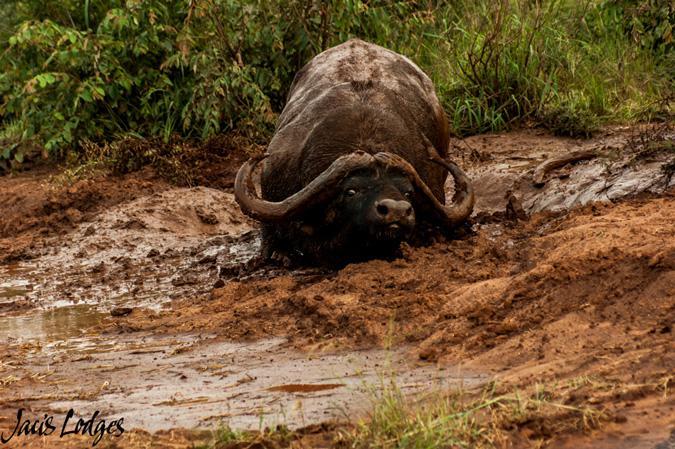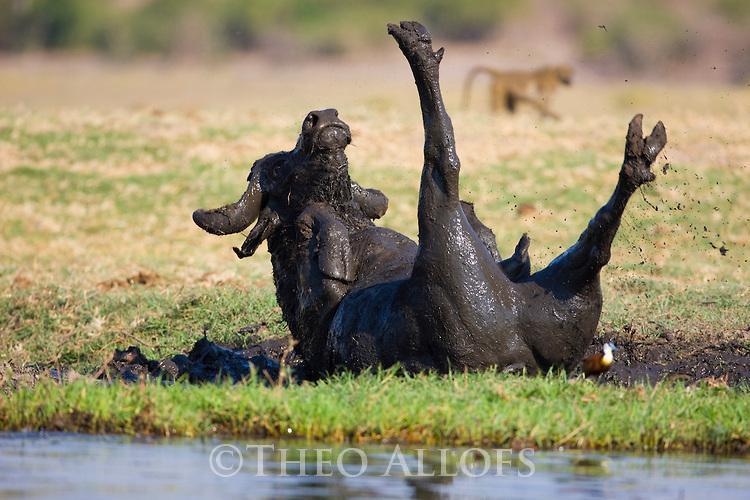The first image is the image on the left, the second image is the image on the right. Considering the images on both sides, is "The right image shows one muddy water buffalo lying on its back with its hind legs extended up in the air." valid? Answer yes or no. Yes. The first image is the image on the left, the second image is the image on the right. For the images displayed, is the sentence "The right image shows a single bull rolling on its back with legs in the air, while the left image shows a single bull wading through mud." factually correct? Answer yes or no. Yes. 